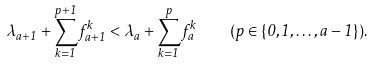<formula> <loc_0><loc_0><loc_500><loc_500>\lambda _ { a + 1 } + \sum _ { k = 1 } ^ { p + 1 } f _ { a + 1 } ^ { k } < \lambda _ { a } + \sum _ { k = 1 } ^ { p } f _ { a } ^ { k } \quad ( p \in \{ 0 , 1 , \dots , a - 1 \} ) .</formula> 